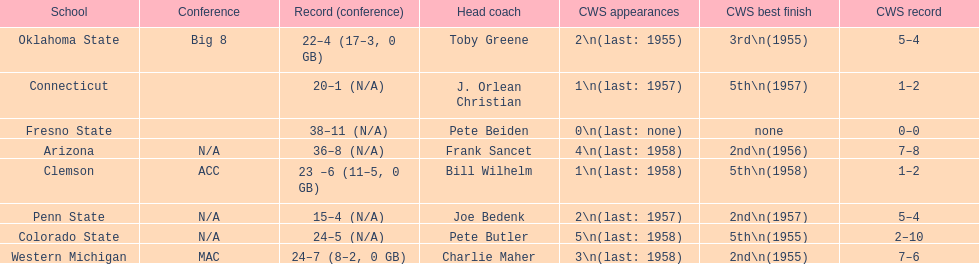How many teams had their cws best finish in 1955? 3. 